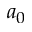<formula> <loc_0><loc_0><loc_500><loc_500>a _ { 0 }</formula> 